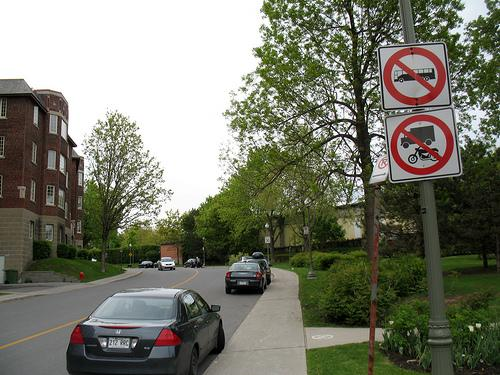How many signs have a diagonal line through them? two 